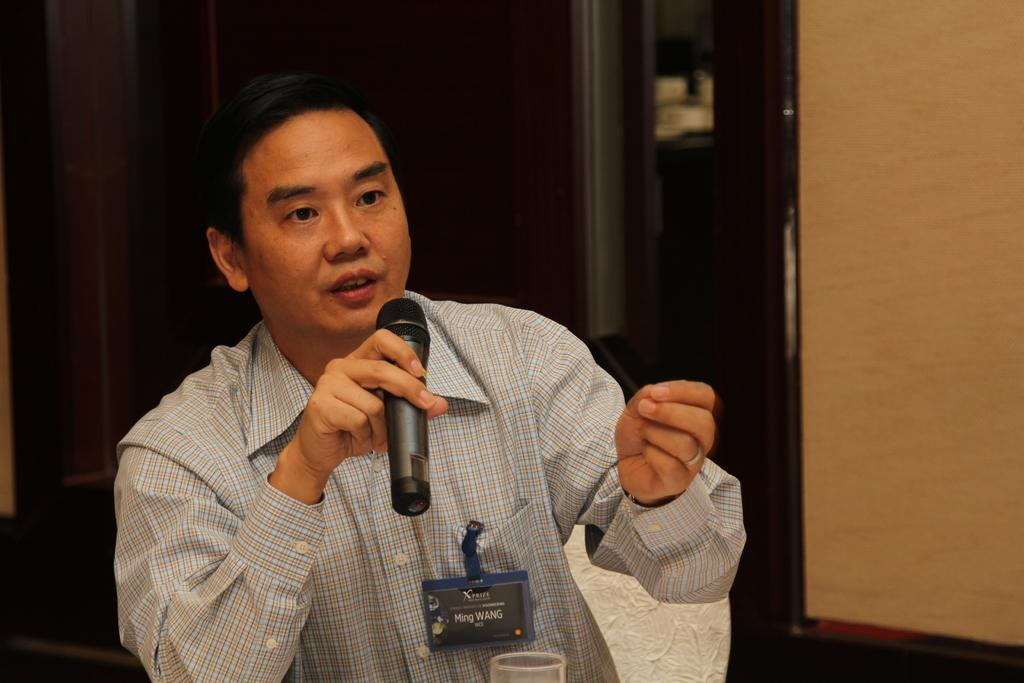Who is the main subject in the image? There is a man in the image. What is the man wearing? The man is wearing a shirt. What is the man holding in the image? The man is holding a microphone. What is the man doing in the image? The man is talking. Can you describe any additional details about the man's attire? There is a badge on the man's pocket. What can be seen in the background of the image? There is a wall in the background of the image. How does the man's anger affect the blood pressure of the audience in the image? There is no indication of the man's anger or the audience's blood pressure in the image. 